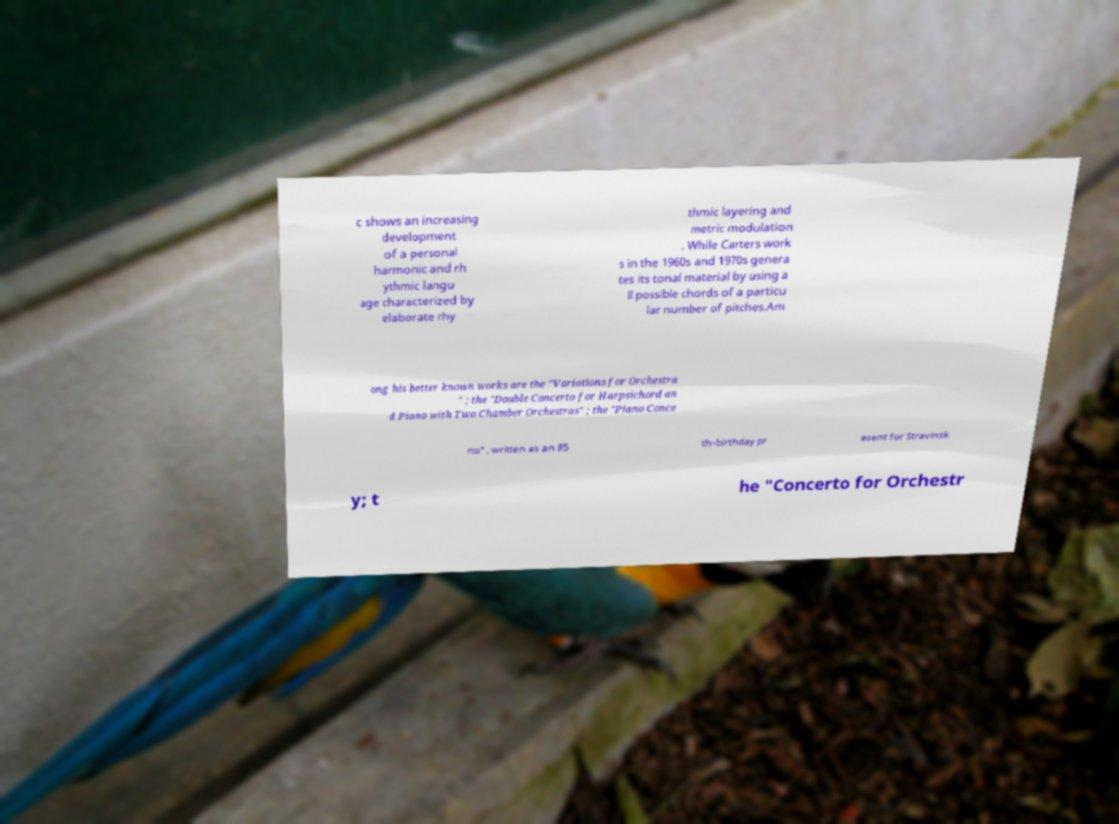What messages or text are displayed in this image? I need them in a readable, typed format. c shows an increasing development of a personal harmonic and rh ythmic langu age characterized by elaborate rhy thmic layering and metric modulation . While Carters work s in the 1960s and 1970s genera tes its tonal material by using a ll possible chords of a particu lar number of pitches.Am ong his better known works are the "Variations for Orchestra " ; the "Double Concerto for Harpsichord an d Piano with Two Chamber Orchestras" ; the "Piano Conce rto" , written as an 85 th-birthday pr esent for Stravinsk y; t he "Concerto for Orchestr 